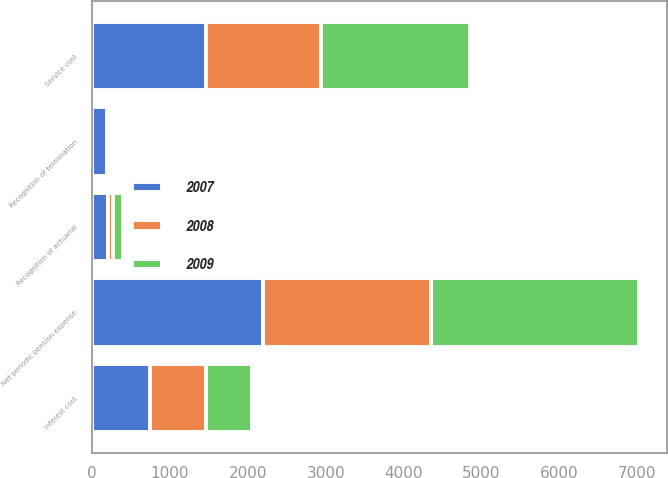Convert chart to OTSL. <chart><loc_0><loc_0><loc_500><loc_500><stacked_bar_chart><ecel><fcel>Service cost<fcel>Interest cost<fcel>Recognition of actuarial<fcel>Recognition of termination<fcel>Net periodic pension expense<nl><fcel>2007<fcel>1465<fcel>742<fcel>200<fcel>192<fcel>2199<nl><fcel>2008<fcel>1470<fcel>717<fcel>74<fcel>40<fcel>2153<nl><fcel>2009<fcel>1922<fcel>599<fcel>129<fcel>24<fcel>2674<nl></chart> 